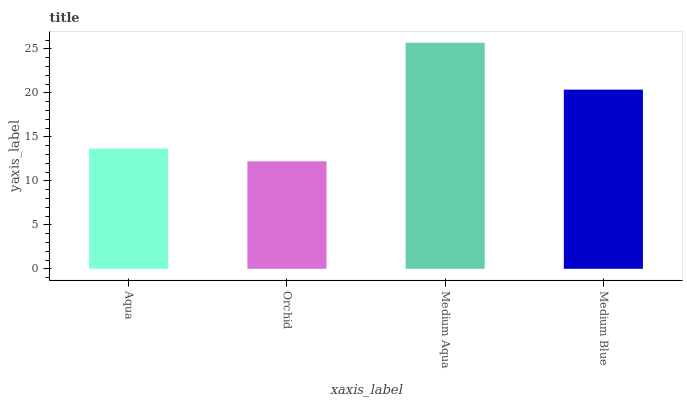Is Medium Aqua the minimum?
Answer yes or no. No. Is Orchid the maximum?
Answer yes or no. No. Is Medium Aqua greater than Orchid?
Answer yes or no. Yes. Is Orchid less than Medium Aqua?
Answer yes or no. Yes. Is Orchid greater than Medium Aqua?
Answer yes or no. No. Is Medium Aqua less than Orchid?
Answer yes or no. No. Is Medium Blue the high median?
Answer yes or no. Yes. Is Aqua the low median?
Answer yes or no. Yes. Is Medium Aqua the high median?
Answer yes or no. No. Is Orchid the low median?
Answer yes or no. No. 